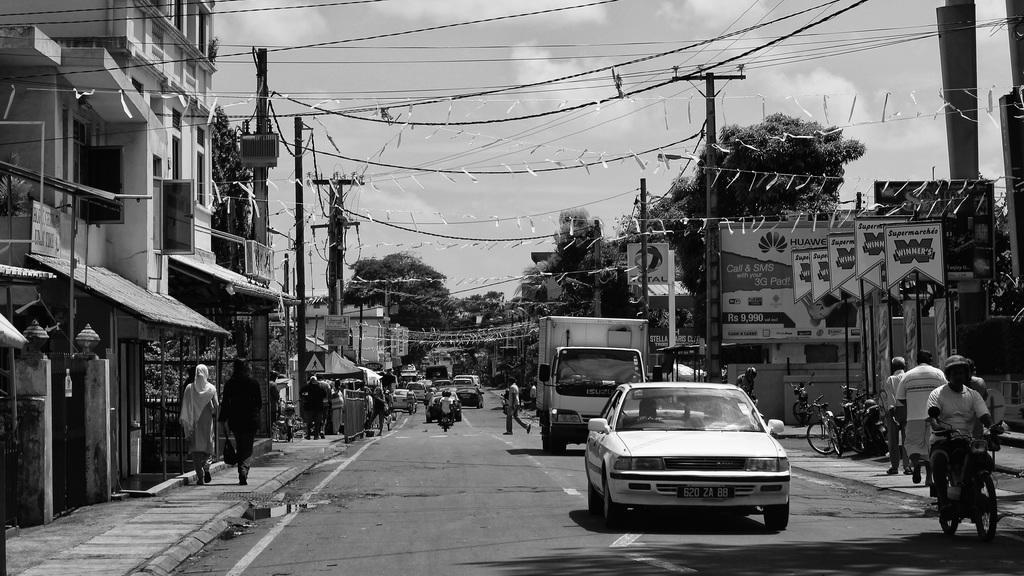How would you summarize this image in a sentence or two? This picture shows a road where we see few buildings on the sides and we see few trees and a cloudy sky and we see people walking on the side walk and people riding motorcycles and some moving vehicles on the road and we see electrical poles on the side 